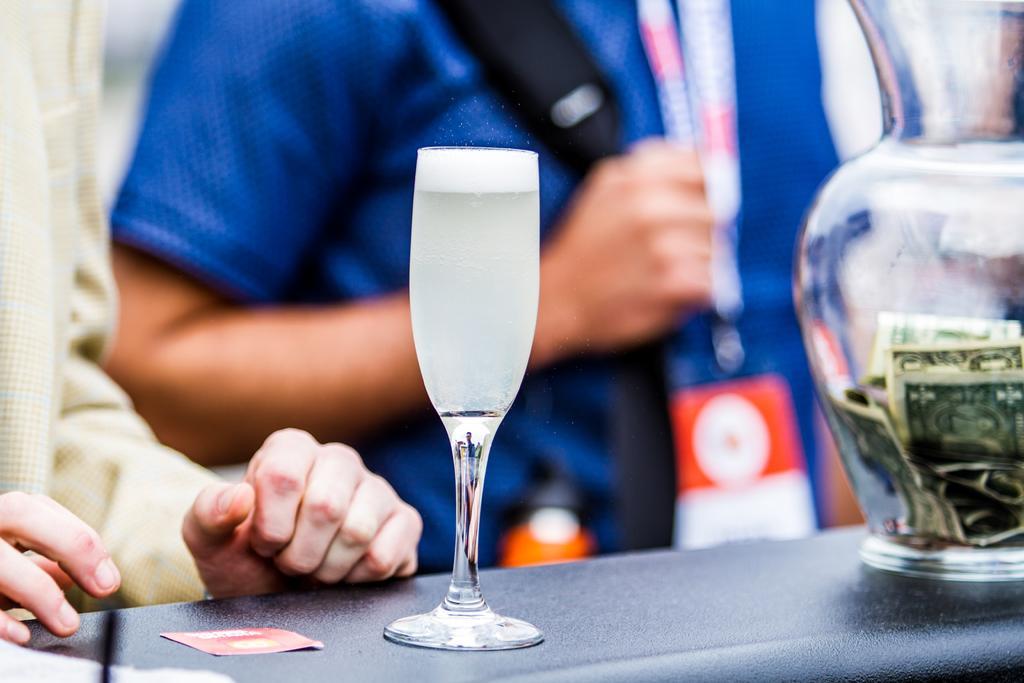In one or two sentences, can you explain what this image depicts? In this image we can see group of persons. One person is carrying a bag. In the foreground we can see a vase with currency notes, a glass and a card placed on the surface. 